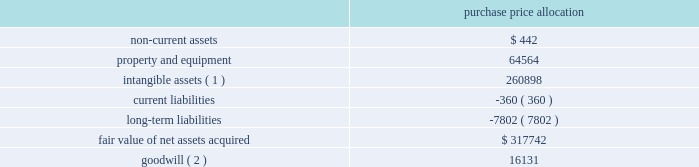American tower corporation and subsidiaries notes to consolidated financial statements u.s .
Acquisitions 2014during the year ended december 31 , 2010 , the company acquired 548 towers through multiple acquisitions in the united states for an aggregate purchase price of $ 329.3 million and contingent consideration of approximately $ 4.6 million .
The acquisition of these towers is consistent with the company 2019s strategy to expand in selected geographic areas and have been accounted for as business combinations .
The table summarizes the preliminary allocation of the aggregate purchase consideration paid and the amounts of assets acquired and liabilities assumed based on the estimated fair value of the acquired assets and assumed liabilities at the date of acquisition ( in thousands ) : purchase price allocation .
( 1 ) consists of customer relationships of approximately $ 205.4 million and network location intangibles of approximately $ 55.5 million .
The customer relationships and network location intangibles are being amortized on a straight-line basis over a period of 20 years .
( 2 ) goodwill is expected to be deductible for income tax purposes .
The goodwill was allocated to the domestic rental and management segment .
The allocation of the purchase price will be finalized upon completion of analyses of the fair value of the assets acquired and liabilities assumed .
South africa acquisition 2014on november 4 , 2010 , the company entered into a definitive agreement with cell c ( pty ) limited to purchase up to approximately 1400 existing towers , and up to 1800 additional towers that either are under construction or will be constructed , for an aggregate purchase price of up to approximately $ 430 million .
The company anticipates closing the purchase of up to 1400 existing towers during 2011 , subject to customary closing conditions .
Other transactions coltel transaction 2014on september 3 , 2010 , the company entered into a definitive agreement to purchase the exclusive use rights for towers in colombia from colombia telecomunicaciones s.a .
E.s.p .
( 201ccoltel 201d ) until 2023 , when ownership of the towers will transfer to the company at no additional cost .
Pursuant to that agreement , the company completed the purchase of exclusive use rights for 508 towers for an aggregate purchase price of $ 86.8 million during the year ended december 31 , 2010 .
The company expects to complete the purchase of the exclusive use rights for an additional 180 towers by the end of 2011 , subject to customary closing conditions .
The transaction has been accounted for as a capital lease , with the aggregated purchase price being allocated to property and equipment and non-current assets .
Joint venture with mtn group 2014on december 6 , 2010 , the company entered into a definitive agreement with mtn group limited ( 201cmtn group 201d ) to establish a joint venture in ghana ( 201ctowerco ghana 201d ) .
Towerco ghana , which will be managed by the company , will be owned by a holding company of which a wholly owned american tower subsidiary will hold a 51% ( 51 % ) share and a wholly owned mtn group subsidiary ( 201cmtn ghana 201d ) will hold a 49% ( 49 % ) share .
The transaction involves the sale of up to 1876 of mtn ghana 2019s existing sites to .
What is the annual amortization expense related to customer relationships , in millions? 
Computations: (205.4 / 20)
Answer: 10.27. 